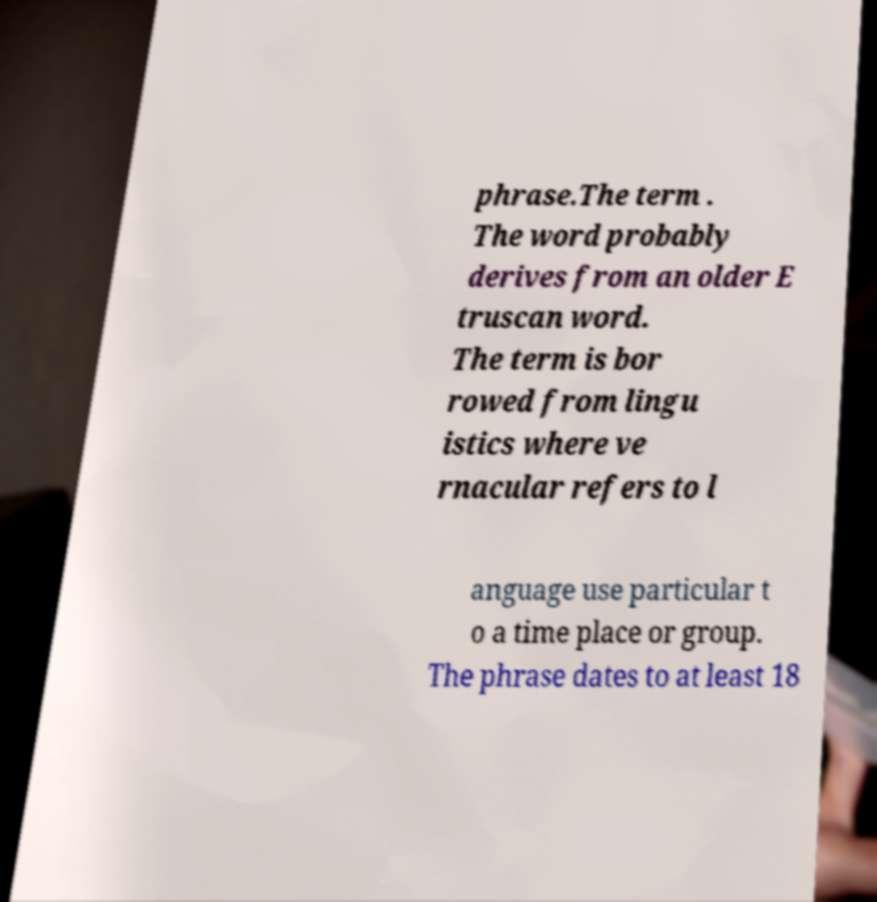Could you assist in decoding the text presented in this image and type it out clearly? phrase.The term . The word probably derives from an older E truscan word. The term is bor rowed from lingu istics where ve rnacular refers to l anguage use particular t o a time place or group. The phrase dates to at least 18 